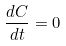<formula> <loc_0><loc_0><loc_500><loc_500>\frac { d C } { d t } = 0</formula> 